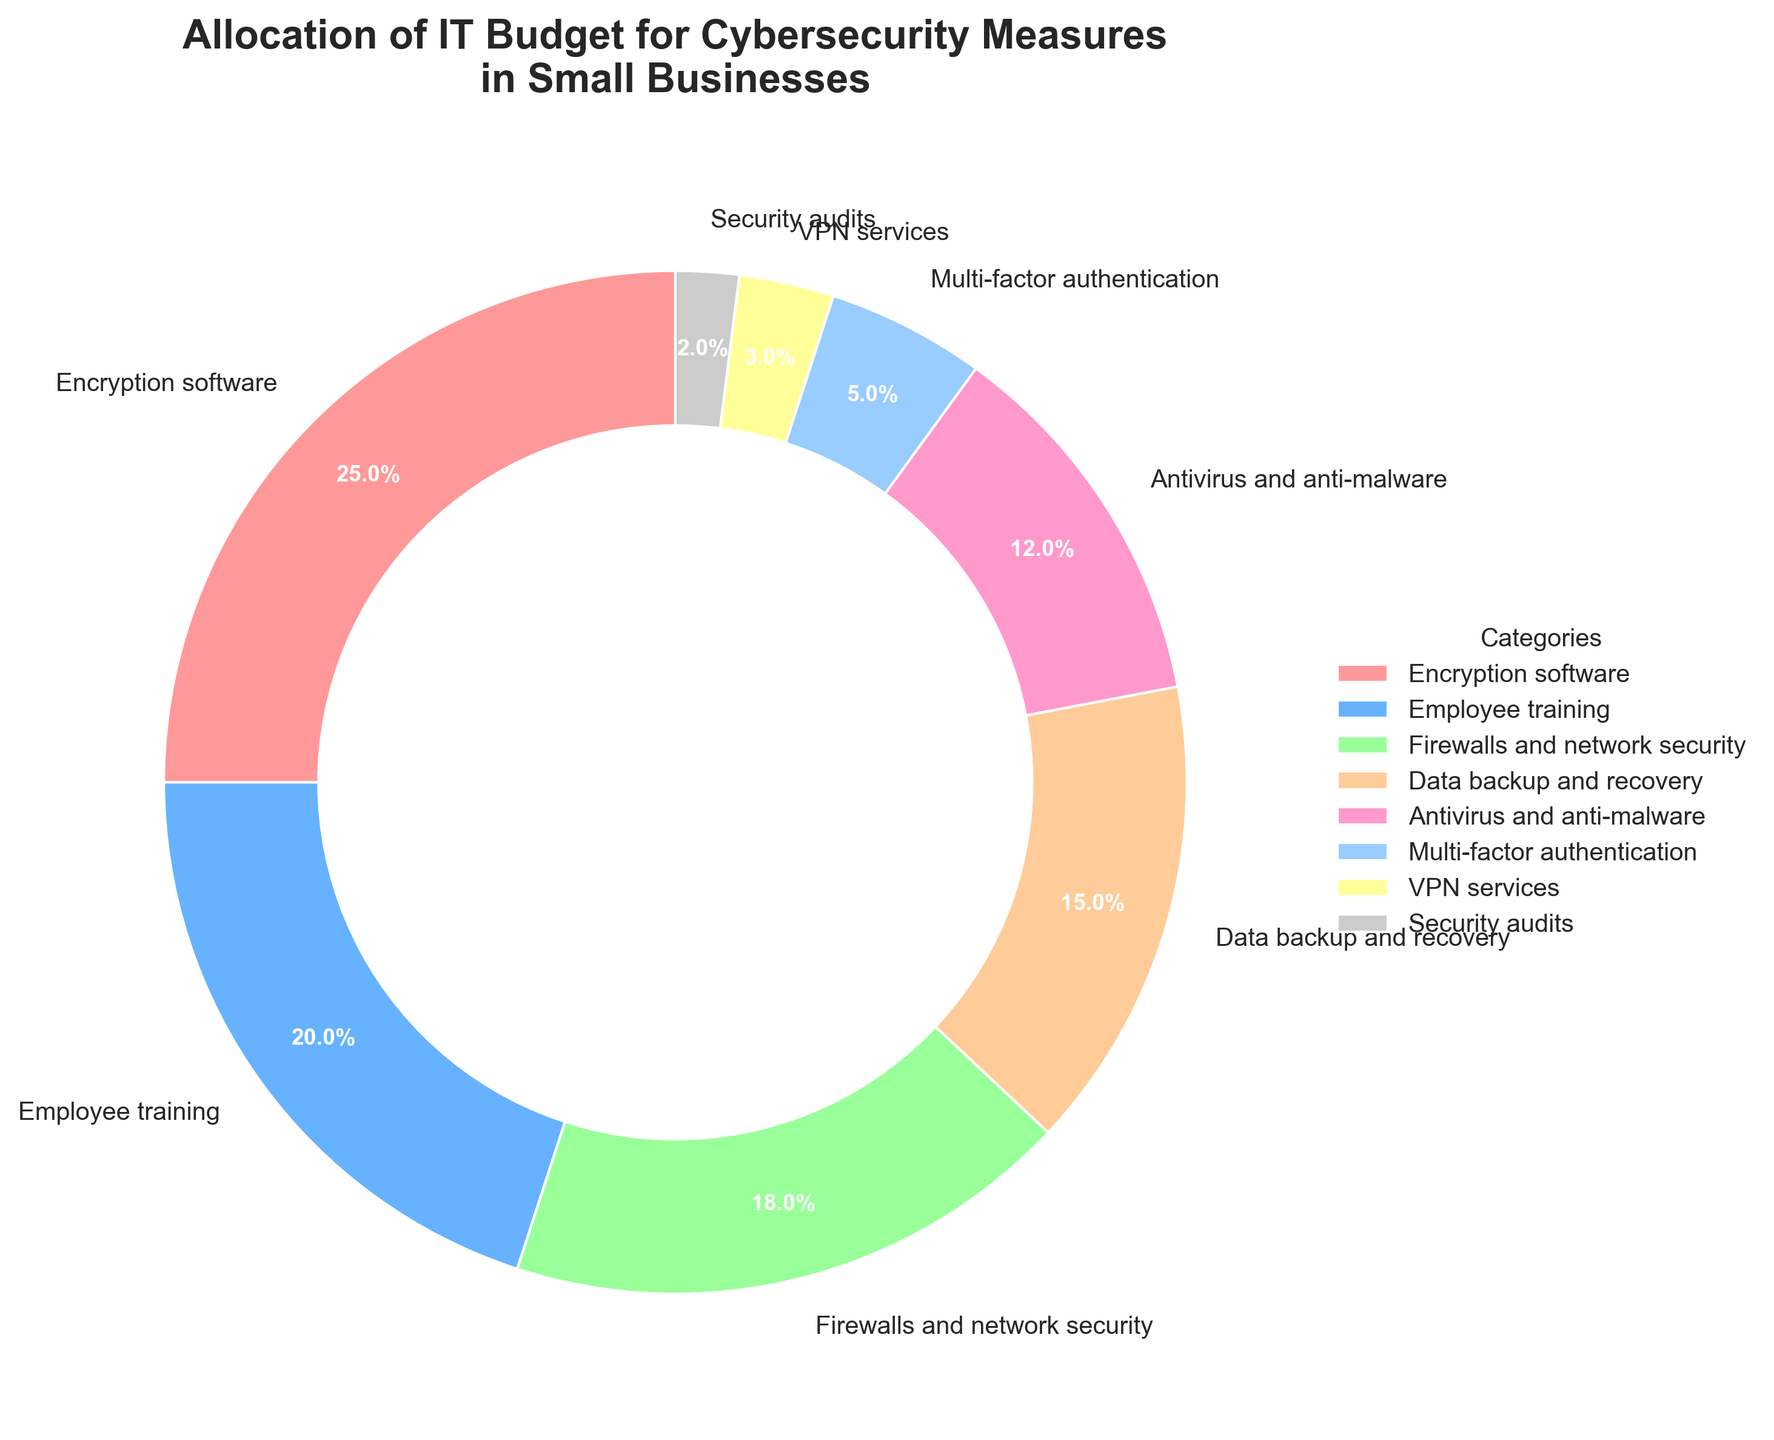What percentage of the IT budget is spent on encryption software and employee training combined? The percentage for encryption software is 25%, and for employee training, it is 20%. Adding these together, 25% + 20% = 45%.
Answer: 45% How does the budget for antivirus and anti-malware compare to that for firewalls and network security? The budget for antivirus and anti-malware is 12%, while for firewalls and network security, it is 18%. Since 12% is less than 18%, the budget for antivirus and anti-malware is lower.
Answer: Lower What is the difference between the highest and lowest budget categories? The highest budget category is encryption software at 25%, and the lowest is security audits at 2%. The difference is 25% - 2% = 23%.
Answer: 23% Is the percentage allocated to data backup and recovery greater than that for multi-factor authentication and VPN services combined? Data backup and recovery has 15%, while multi-factor authentication has 5%, and VPN services have 3%. Combined, these two add up to 5% + 3% = 8%. Since 15% is greater than 8%, the percentage for data backup and recovery is greater.
Answer: Yes Which category has the smallest budget, and what is its percentage? The category with the smallest budget is security audits, and its percentage is 2%.
Answer: Security audits, 2% How does the expenditure on firewalls and network security compare with that on VPN services? Firewalls and network security have a budget of 18%, whereas VPN services have 3%. Since 18% is greater than 3%, the expenditure on firewalls and network security is higher.
Answer: Higher Which category is represented by the blue section of the pie chart? The blue section of the pie chart represents employee training, which has a percentage of 20%.
Answer: Employee training, 20% What is the total budget percentage for all categories that have more than 10% allocation? The categories with more than 10% are encryption software (25%), employee training (20%), firewalls and network security (18%), data backup and recovery (15%), and antivirus and anti-malware (12%). Adding these, 25% + 20% + 18% + 15% + 12% = 90%.
Answer: 90% Are multi-factor authentication and VPN services combined the smallest or second smallest category by percentage? Multi-factor authentication is 5%, and VPN services are 3%, combined they are 5% + 3% = 8%. Security audits are 2%, so MFA and VPN combined come in as the second smallest category.
Answer: Second smallest 